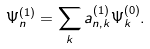Convert formula to latex. <formula><loc_0><loc_0><loc_500><loc_500>\Psi _ { n } ^ { ( 1 ) } & = \sum _ { k } a _ { n , k } ^ { ( 1 ) } \Psi _ { k } ^ { ( 0 ) } .</formula> 